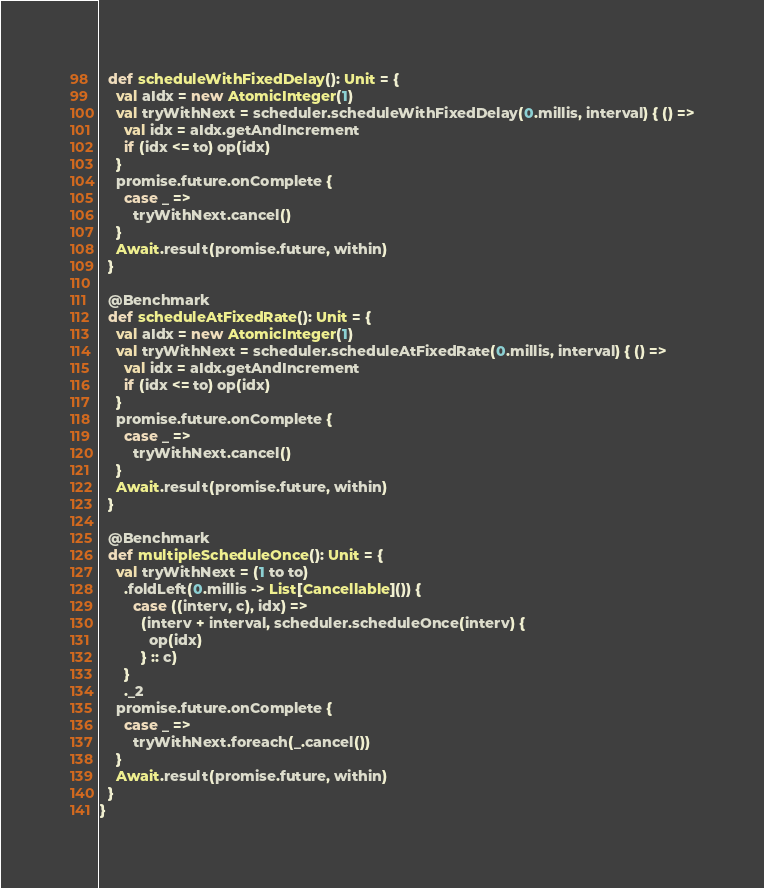Convert code to text. <code><loc_0><loc_0><loc_500><loc_500><_Scala_>  def scheduleWithFixedDelay(): Unit = {
    val aIdx = new AtomicInteger(1)
    val tryWithNext = scheduler.scheduleWithFixedDelay(0.millis, interval) { () =>
      val idx = aIdx.getAndIncrement
      if (idx <= to) op(idx)
    }
    promise.future.onComplete {
      case _ =>
        tryWithNext.cancel()
    }
    Await.result(promise.future, within)
  }

  @Benchmark
  def scheduleAtFixedRate(): Unit = {
    val aIdx = new AtomicInteger(1)
    val tryWithNext = scheduler.scheduleAtFixedRate(0.millis, interval) { () =>
      val idx = aIdx.getAndIncrement
      if (idx <= to) op(idx)
    }
    promise.future.onComplete {
      case _ =>
        tryWithNext.cancel()
    }
    Await.result(promise.future, within)
  }

  @Benchmark
  def multipleScheduleOnce(): Unit = {
    val tryWithNext = (1 to to)
      .foldLeft(0.millis -> List[Cancellable]()) {
        case ((interv, c), idx) =>
          (interv + interval, scheduler.scheduleOnce(interv) {
            op(idx)
          } :: c)
      }
      ._2
    promise.future.onComplete {
      case _ =>
        tryWithNext.foreach(_.cancel())
    }
    Await.result(promise.future, within)
  }
}
</code> 